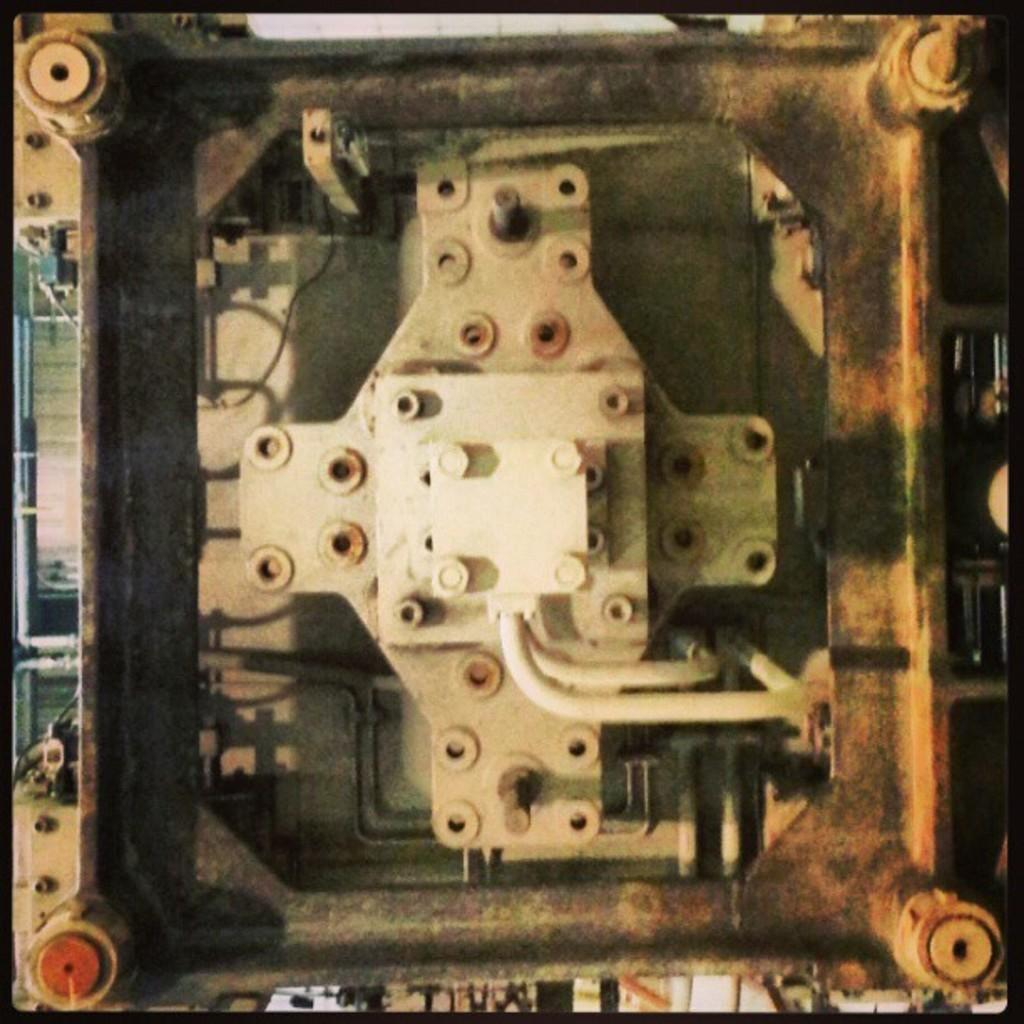What type of structure is visible in the image? There is a metal structure in the image. What type of car does the brother drive in the image? There is no car or brother present in the image; it only features a metal structure. 